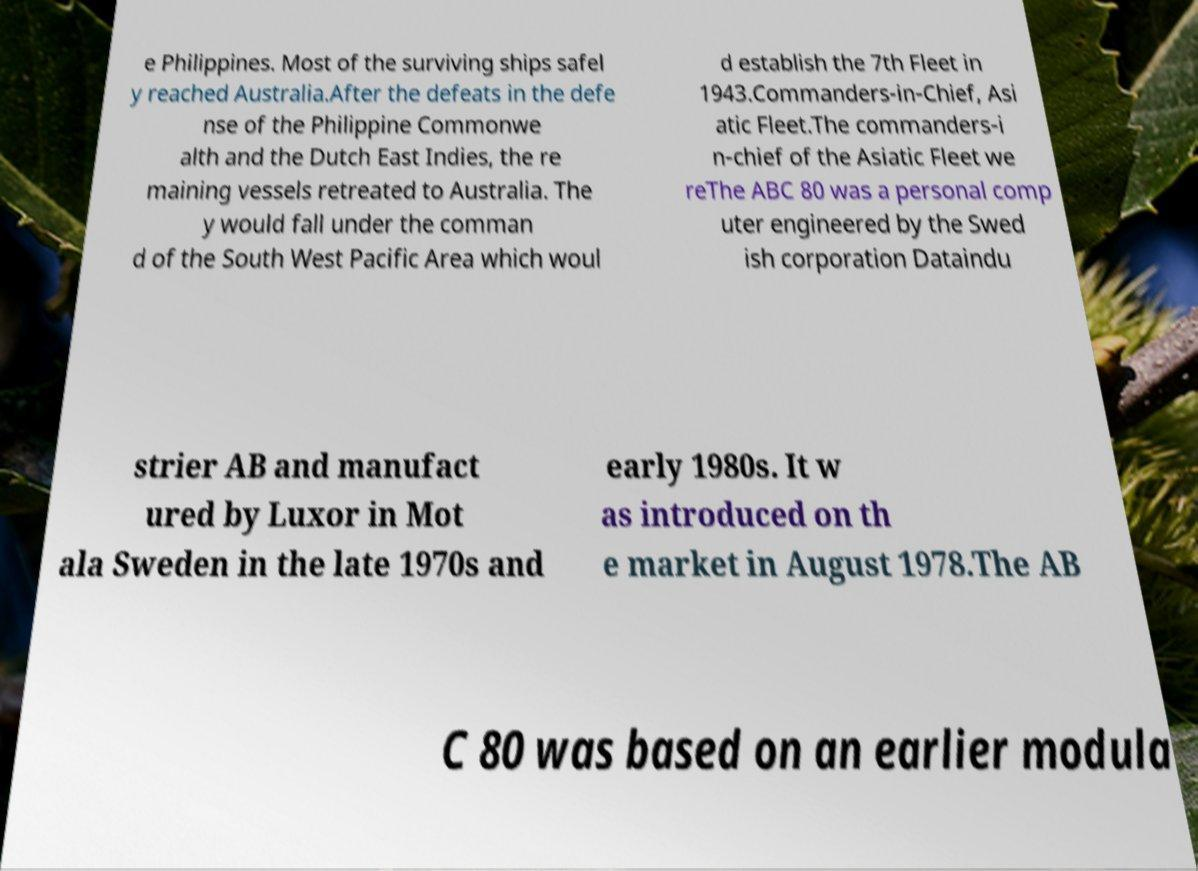Please read and relay the text visible in this image. What does it say? e Philippines. Most of the surviving ships safel y reached Australia.After the defeats in the defe nse of the Philippine Commonwe alth and the Dutch East Indies, the re maining vessels retreated to Australia. The y would fall under the comman d of the South West Pacific Area which woul d establish the 7th Fleet in 1943.Commanders-in-Chief, Asi atic Fleet.The commanders-i n-chief of the Asiatic Fleet we reThe ABC 80 was a personal comp uter engineered by the Swed ish corporation Dataindu strier AB and manufact ured by Luxor in Mot ala Sweden in the late 1970s and early 1980s. It w as introduced on th e market in August 1978.The AB C 80 was based on an earlier modula 